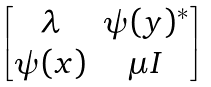<formula> <loc_0><loc_0><loc_500><loc_500>\begin{bmatrix} \lambda & \psi ( y ) ^ { * } \\ \psi ( x ) & \mu I \end{bmatrix}</formula> 